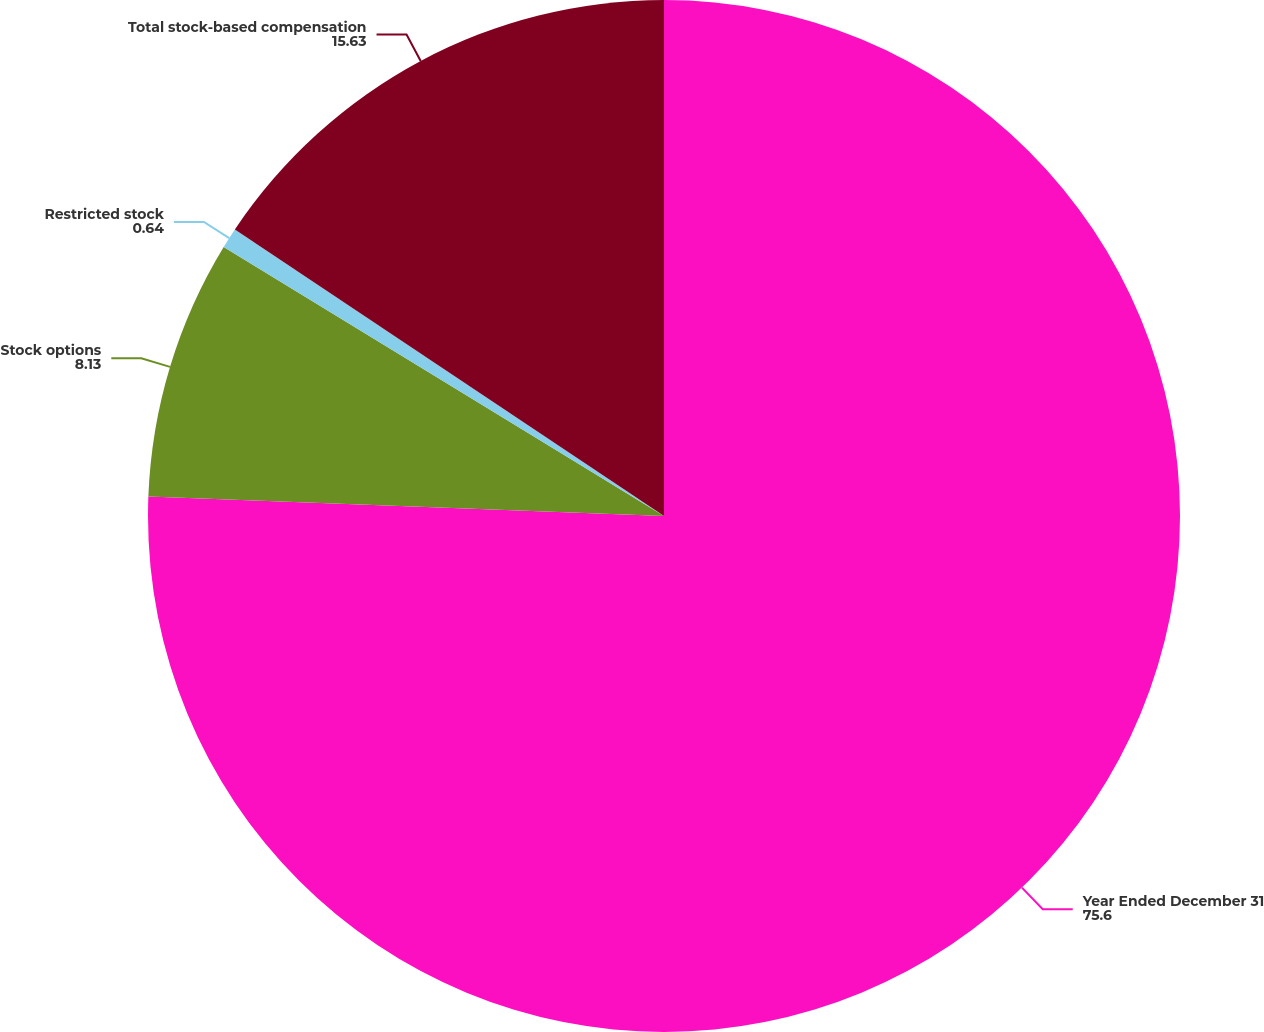Convert chart to OTSL. <chart><loc_0><loc_0><loc_500><loc_500><pie_chart><fcel>Year Ended December 31<fcel>Stock options<fcel>Restricted stock<fcel>Total stock-based compensation<nl><fcel>75.6%<fcel>8.13%<fcel>0.64%<fcel>15.63%<nl></chart> 